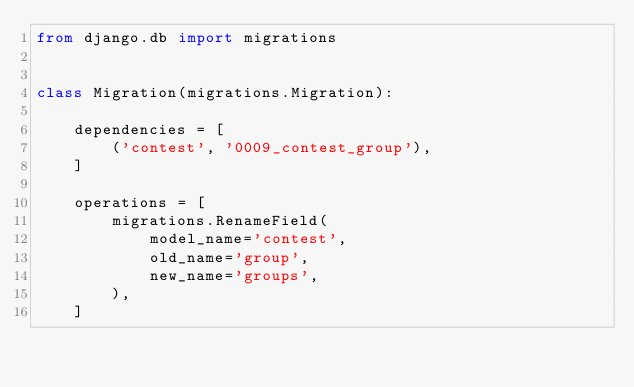Convert code to text. <code><loc_0><loc_0><loc_500><loc_500><_Python_>from django.db import migrations


class Migration(migrations.Migration):

    dependencies = [
        ('contest', '0009_contest_group'),
    ]

    operations = [
        migrations.RenameField(
            model_name='contest',
            old_name='group',
            new_name='groups',
        ),
    ]
</code> 